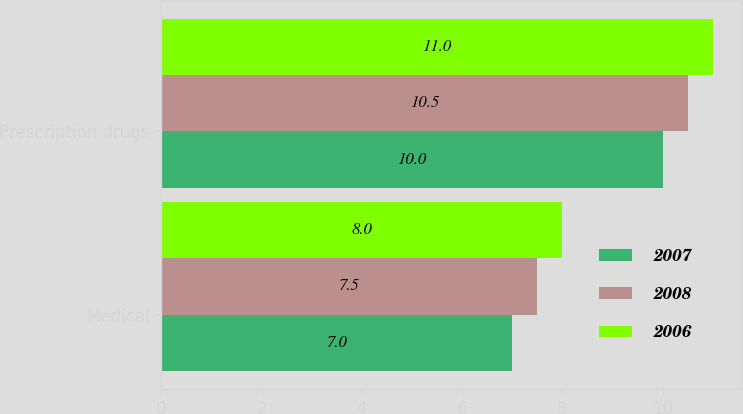Convert chart to OTSL. <chart><loc_0><loc_0><loc_500><loc_500><stacked_bar_chart><ecel><fcel>Medical<fcel>Prescription drugs<nl><fcel>2007<fcel>7<fcel>10<nl><fcel>2008<fcel>7.5<fcel>10.5<nl><fcel>2006<fcel>8<fcel>11<nl></chart> 